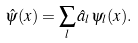Convert formula to latex. <formula><loc_0><loc_0><loc_500><loc_500>\hat { \psi } ( { x } ) = \sum _ { l } \hat { a } _ { l } \psi _ { l } ( { x } ) .</formula> 